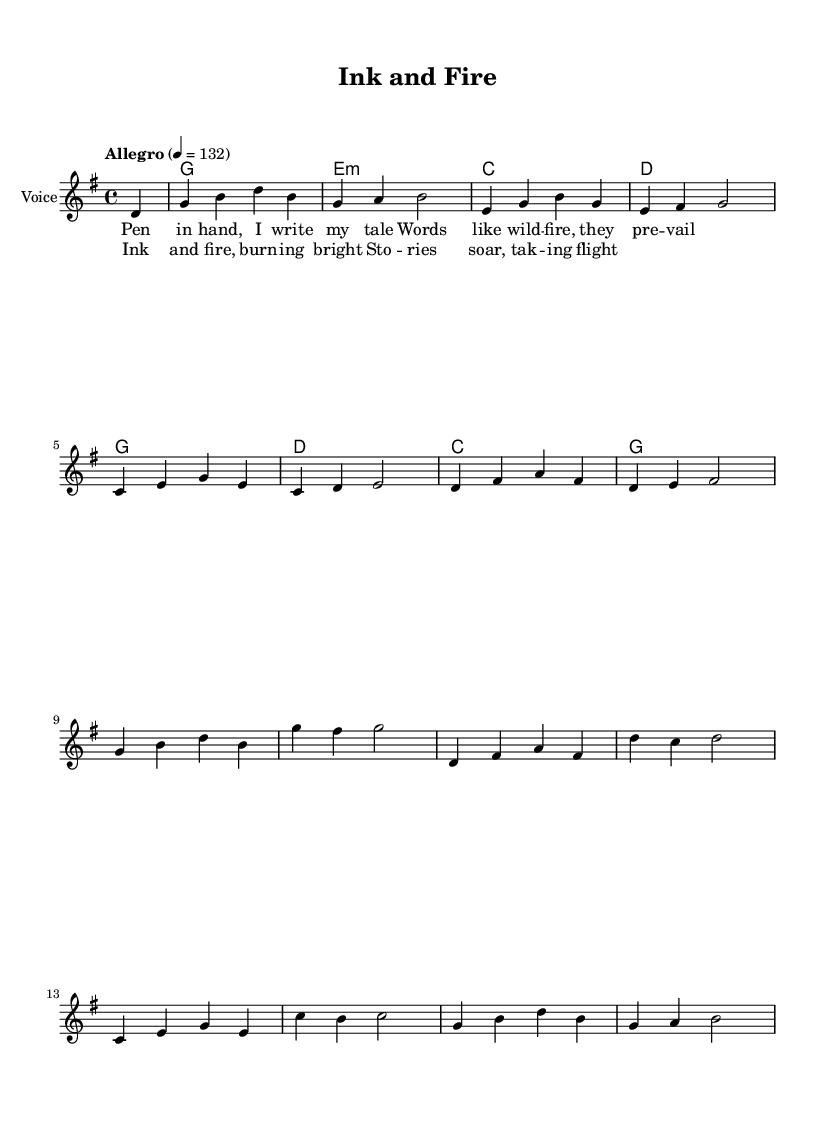What is the key signature of this music? The key signature is G major, which has one sharp (F#). This is determined by looking at the key signature indicated at the beginning of the sheet music.
Answer: G major What is the time signature of this music? The time signature is 4/4, which is indicated at the beginning of the sheet music. This means there are four beats in each measure and the quarter note gets one beat.
Answer: 4/4 What is the tempo marking for this piece? The tempo marking is "Allegro," which suggests a fast and lively pace. The beats per minute are indicated as 132, showing the speed at which the piece should be played.
Answer: Allegro How many measures are in the melody? There are 12 measures in the melody section, which can be counted by observing the vertical bar lines that separate the measures in the music.
Answer: 12 Which chords are used in the chorus? The chords in the chorus include G, E minor, C, and D. These chords can be identified in the chord symbols written in the choruses’ corresponding section.
Answer: G, E minor, C, D What is the overall mood of this country rock anthem based on the lyrics? The lyrics convey a sense of empowerment and inspiration through storytelling, which is characteristic of upbeat country rock anthems. This is inferred from phrases expressing fire and flight, suggesting energy and passion.
Answer: Upbeat 